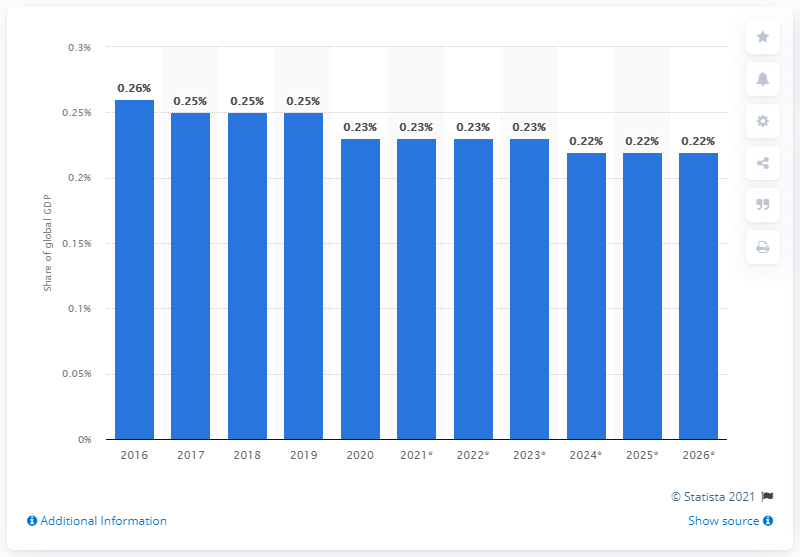Identify some key points in this picture. In 2020, Greece's share of GDP was approximately 0.23%. 